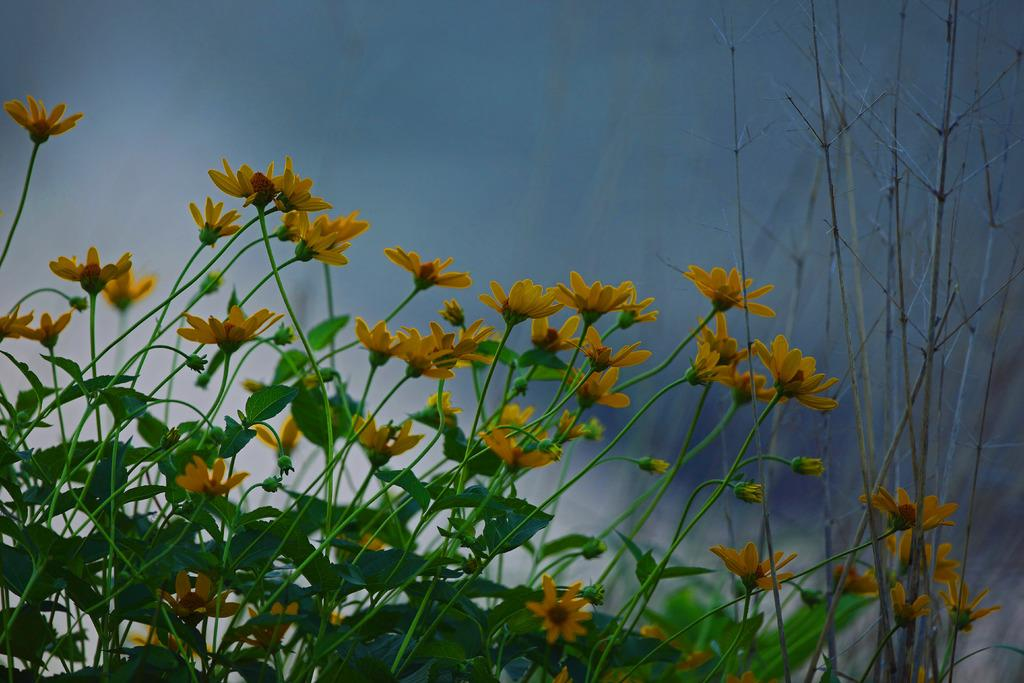What type of plants are in the foreground of the image? There are flower plants in the foreground of the image. What can be seen in the background of the image? The sky is visible in the background of the image. How many pins are holding the flowers in the image? There is no mention of pins in the image, so it cannot be determined if any are present. 